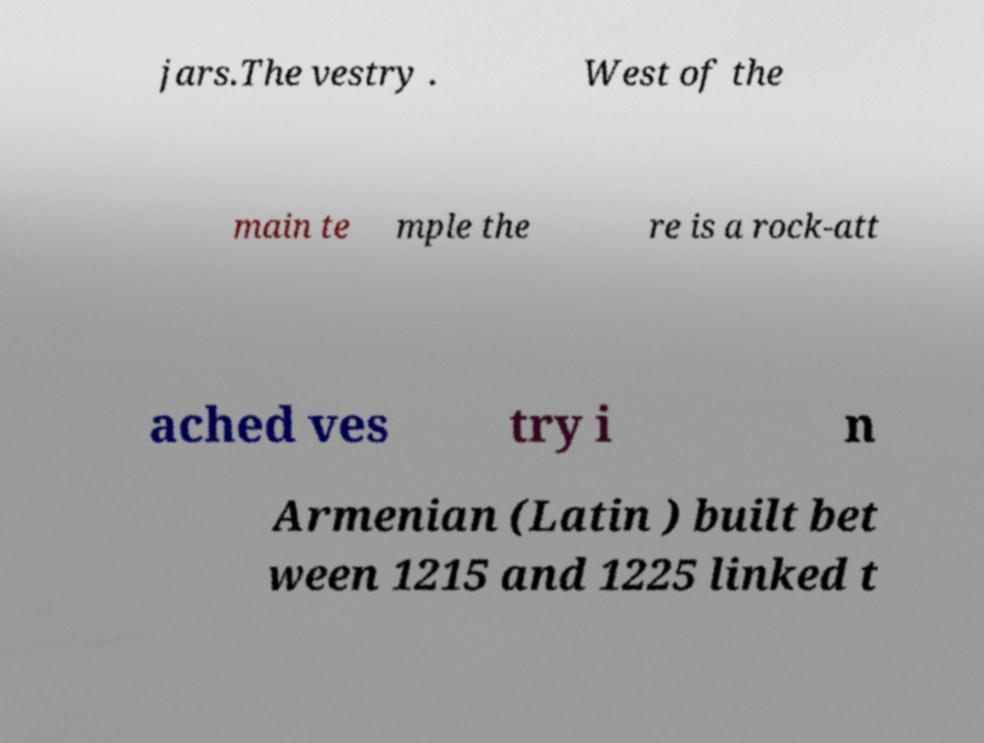Can you read and provide the text displayed in the image?This photo seems to have some interesting text. Can you extract and type it out for me? jars.The vestry . West of the main te mple the re is a rock-att ached ves try i n Armenian (Latin ) built bet ween 1215 and 1225 linked t 